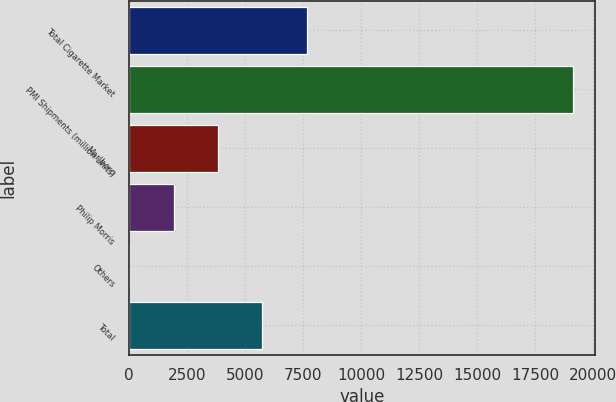Convert chart to OTSL. <chart><loc_0><loc_0><loc_500><loc_500><bar_chart><fcel>Total Cigarette Market<fcel>PMI Shipments (million units)<fcel>Marlboro<fcel>Philip Morris<fcel>Others<fcel>Total<nl><fcel>7651<fcel>19123<fcel>3827<fcel>1915<fcel>3<fcel>5739<nl></chart> 